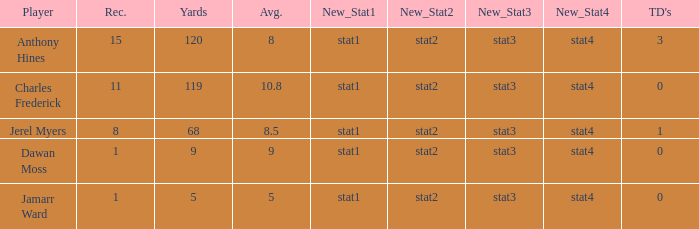What is the average number of TDs when the yards are less than 119, the AVG is larger than 5, and Jamarr Ward is a player? None. 